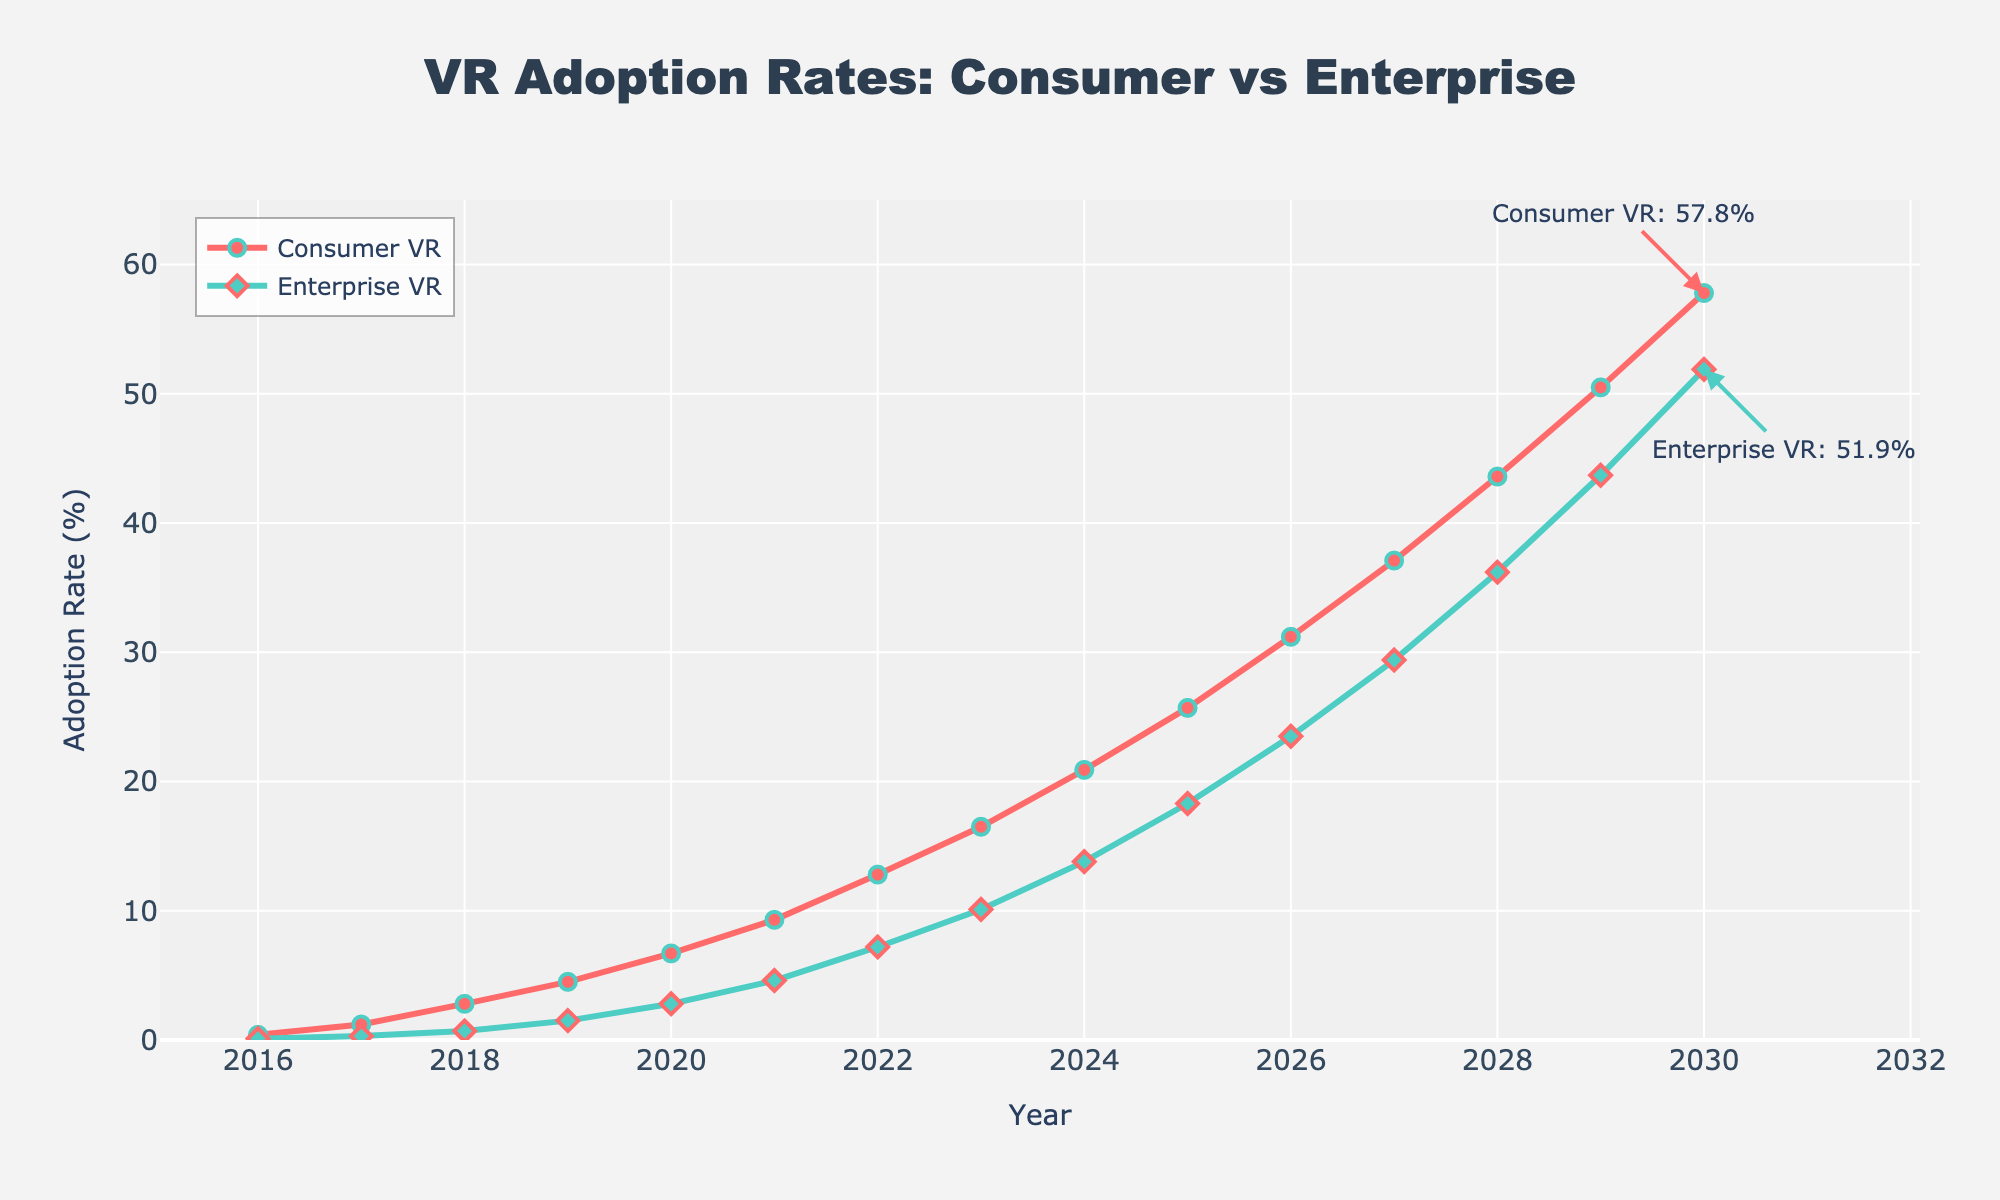What is the VR adoption rate for consumers in 2019? Look at the line representing consumer VR adoption and find the value corresponding to the year 2019.
Answer: 4.5% Which year did enterprise VR adoption surpass 10%? Follow the green line representing enterprise VR adoption and find the first year where the value is greater than 10%.
Answer: 2023 What's the difference in VR adoption rates between consumer and enterprise markets in 2025? Locate the adoption rates for consumer and enterprise VR in 2025, then subtract the enterprise rate from the consumer rate (25.7% - 18.3%).
Answer: 7.4% In which year was the rate of increase in consumer VR adoption the highest? Compare the slope of the red line for each year increment to determine which year had the steepest increase in consumer VR adoption.
Answer: 2029 What is the average VR adoption rate for consumers from 2016 to 2020? Sum the consumer VR adoption rates from 2016 to 2020 and then divide by the number of years (0.4% + 1.2% + 2.8% + 4.5% + 6.7%) / 5.
Answer: 3.12% How much higher is consumer VR adoption compared to enterprise VR adoption in 2030? Locate the adoption rates for both consumer and enterprise VR in 2030 and calculate the difference (57.8% - 51.9%).
Answer: 5.9% What color is used to represent consumer VR adoption? Identify the color of the line and markers representing consumer VR adoption in the chart.
Answer: Red What is the compound annual growth rate (CAGR) of consumer VR adoption from 2016 to 2030? Using the formula for CAGR: (Ending Value/Beginning Value)^(1/Number of Periods) - 1, compute CAGR for consumer VR adoption from 2016 (0.4%) to 2030 (57.8%) over 14 years. Detailed calculations involve finding 57.8/0.4, taking the 1/14th root and subtracting 1.
Answer: 33.7% Compare the growth trends of consumer vs. enterprise VR adoption from 2016 to 2030. Which one grew faster? Analyze the slopes of both lines by observing their growth trajectories from 2016 to 2030. Consumer VR starts with 0.4% and ends at 57.8% while enterprise VR starts at 0.1% and ends at 51.9%.
Answer: Consumer VR grew faster Which year shows a more rapid increase in enterprise VR adoption compared to the previous year? Examine the steepness of the segments of the green line year-over-year to find the year with the most significant positive change in slope.
Answer: 2024 